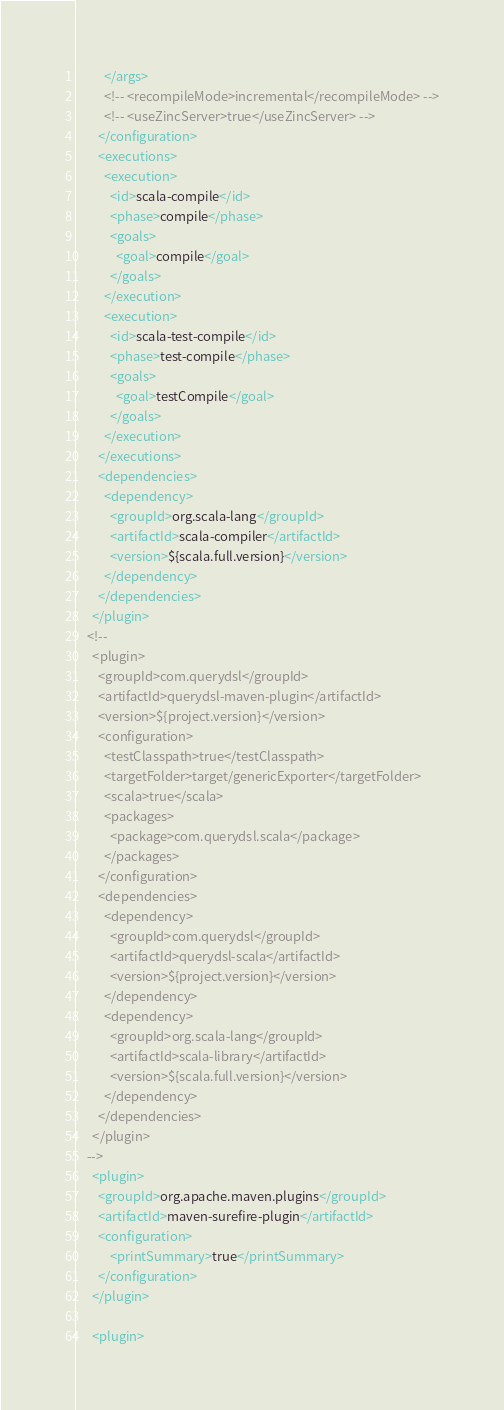<code> <loc_0><loc_0><loc_500><loc_500><_XML_>          </args>
          <!-- <recompileMode>incremental</recompileMode> -->
          <!-- <useZincServer>true</useZincServer> -->
        </configuration>
        <executions>
          <execution>
            <id>scala-compile</id>
            <phase>compile</phase>
            <goals>
              <goal>compile</goal>
            </goals>
          </execution>
          <execution>
            <id>scala-test-compile</id>
            <phase>test-compile</phase>
            <goals>
              <goal>testCompile</goal>
            </goals>
          </execution>
        </executions>
        <dependencies>
          <dependency>
            <groupId>org.scala-lang</groupId>
            <artifactId>scala-compiler</artifactId>
            <version>${scala.full.version}</version>
          </dependency>
        </dependencies>
      </plugin>
    <!--
      <plugin>
        <groupId>com.querydsl</groupId>
        <artifactId>querydsl-maven-plugin</artifactId>
        <version>${project.version}</version>
        <configuration>
          <testClasspath>true</testClasspath>
          <targetFolder>target/genericExporter</targetFolder>
          <scala>true</scala>
          <packages>
            <package>com.querydsl.scala</package>
          </packages>
        </configuration>
        <dependencies>
          <dependency>
            <groupId>com.querydsl</groupId>
            <artifactId>querydsl-scala</artifactId>
            <version>${project.version}</version>
          </dependency>
          <dependency>
            <groupId>org.scala-lang</groupId>
            <artifactId>scala-library</artifactId>
            <version>${scala.full.version}</version>
          </dependency>
        </dependencies>
      </plugin>    
    -->
      <plugin>
        <groupId>org.apache.maven.plugins</groupId>
        <artifactId>maven-surefire-plugin</artifactId>
        <configuration>
            <printSummary>true</printSummary>
        </configuration>                
      </plugin>      
      
      <plugin></code> 